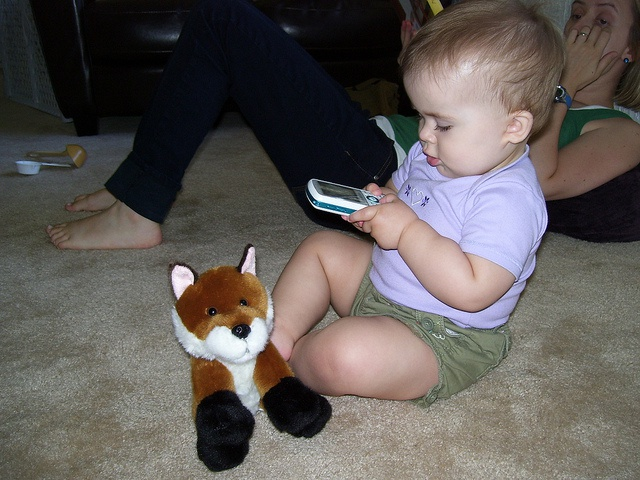Describe the objects in this image and their specific colors. I can see people in black, darkgray, gray, and lavender tones, people in black, gray, and maroon tones, couch in black, gray, and darkblue tones, teddy bear in black, maroon, and lightgray tones, and cell phone in black, white, gray, and darkgray tones in this image. 